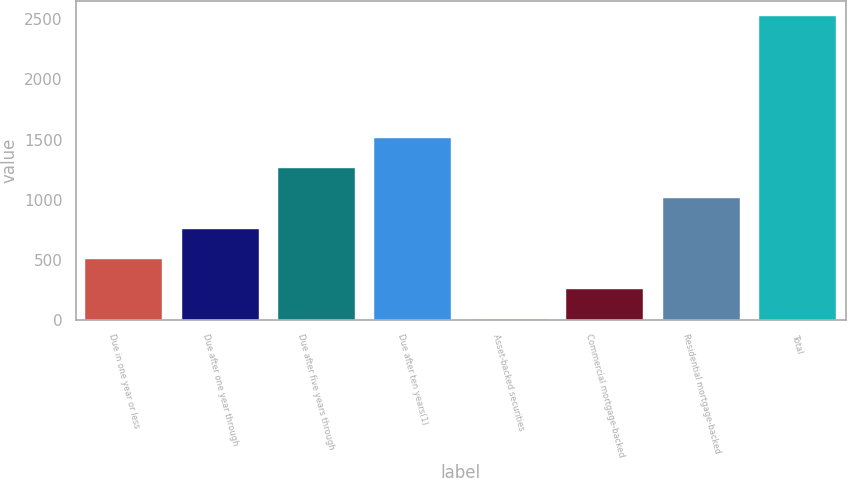Convert chart to OTSL. <chart><loc_0><loc_0><loc_500><loc_500><bar_chart><fcel>Due in one year or less<fcel>Due after one year through<fcel>Due after five years through<fcel>Due after ten years(1)<fcel>Asset-backed securities<fcel>Commercial mortgage-backed<fcel>Residential mortgage-backed<fcel>Total<nl><fcel>507.68<fcel>759.72<fcel>1263.8<fcel>1515.84<fcel>3.6<fcel>255.64<fcel>1011.76<fcel>2524<nl></chart> 